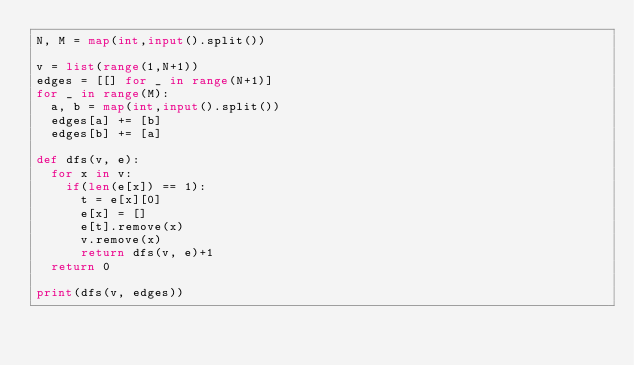<code> <loc_0><loc_0><loc_500><loc_500><_Python_>N, M = map(int,input().split())

v = list(range(1,N+1))
edges = [[] for _ in range(N+1)]
for _ in range(M):
  a, b = map(int,input().split())
  edges[a] += [b]
  edges[b] += [a]

def dfs(v, e):
  for x in v:
    if(len(e[x]) == 1):
      t = e[x][0]
      e[x] = []
      e[t].remove(x)
      v.remove(x)
      return dfs(v, e)+1
  return 0

print(dfs(v, edges))</code> 